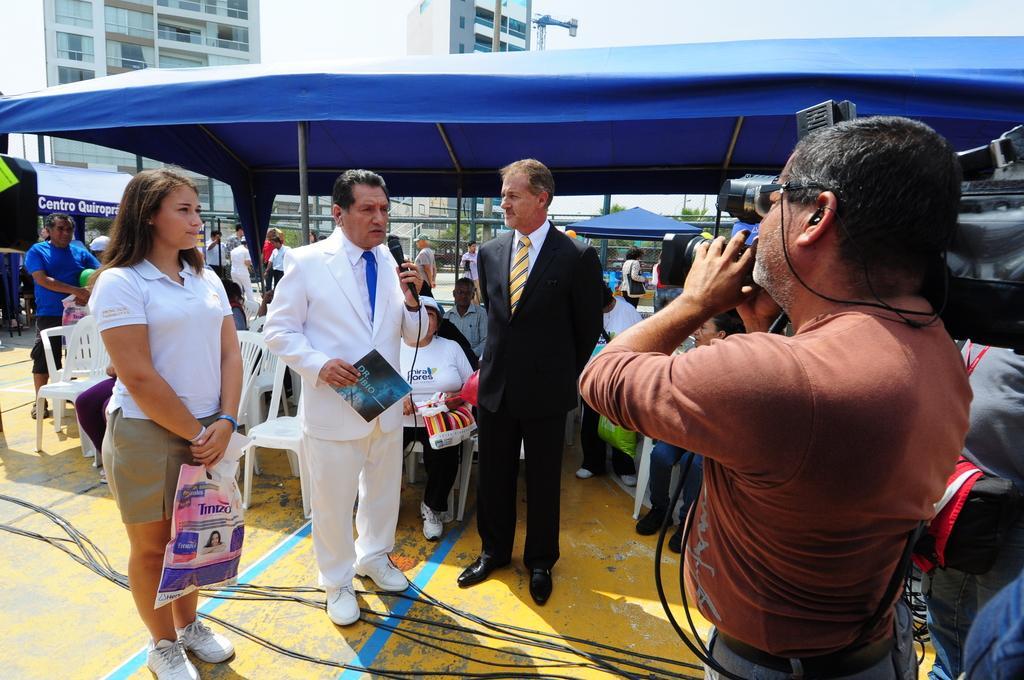Please provide a concise description of this image. On the left side, there is a woman in a white color t-shirt, holding a carry bag and standing on the floor. Beside her, there is a person in a white color suit, holding a poster with a hand, holding a microphone with other hand, speaking and standing. Besides this person, there is another person, standing on the floor, on which there are cables. On the right side, there is a person in a brown color t-shirt, holding a camera and standing. In the background, there are other persons, sitting under a blue color tent, there are buildings, trees, persons and there are clouds in the sky. 